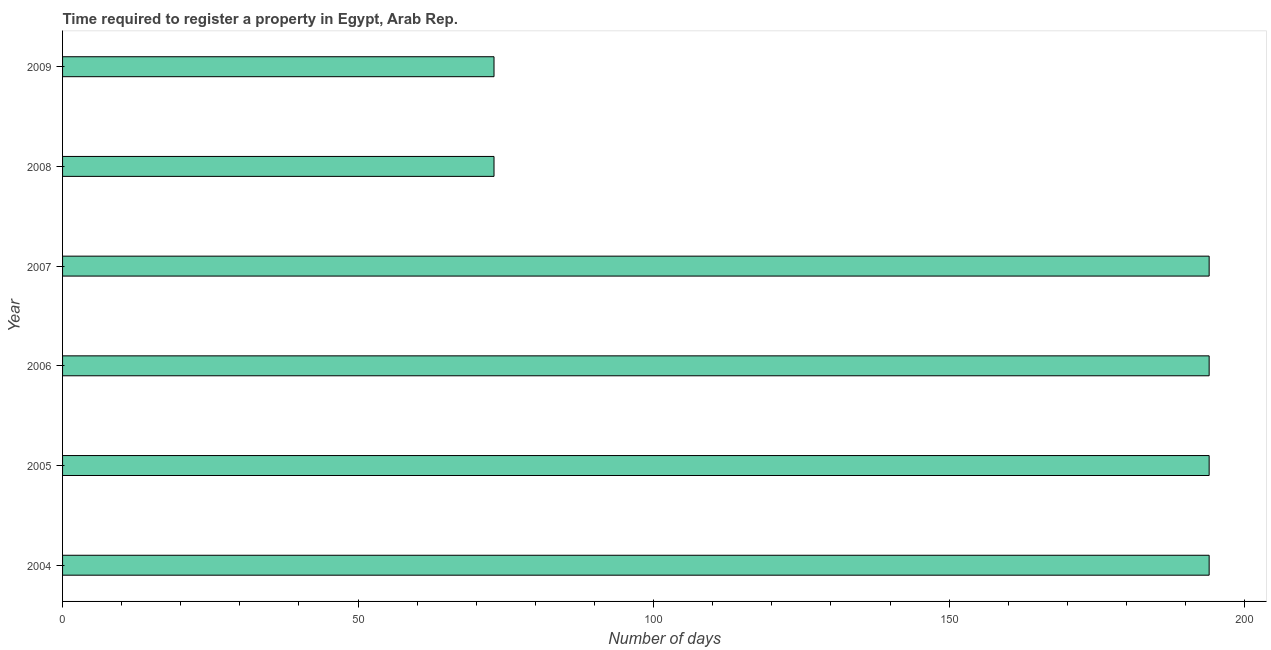What is the title of the graph?
Make the answer very short. Time required to register a property in Egypt, Arab Rep. What is the label or title of the X-axis?
Offer a very short reply. Number of days. What is the label or title of the Y-axis?
Provide a succinct answer. Year. What is the number of days required to register property in 2007?
Give a very brief answer. 194. Across all years, what is the maximum number of days required to register property?
Offer a terse response. 194. In which year was the number of days required to register property maximum?
Offer a terse response. 2004. In which year was the number of days required to register property minimum?
Ensure brevity in your answer.  2008. What is the sum of the number of days required to register property?
Provide a succinct answer. 922. What is the average number of days required to register property per year?
Provide a succinct answer. 153. What is the median number of days required to register property?
Give a very brief answer. 194. In how many years, is the number of days required to register property greater than 30 days?
Your response must be concise. 6. What is the ratio of the number of days required to register property in 2008 to that in 2009?
Your answer should be compact. 1. What is the difference between the highest and the second highest number of days required to register property?
Keep it short and to the point. 0. What is the difference between the highest and the lowest number of days required to register property?
Provide a short and direct response. 121. How many bars are there?
Your answer should be very brief. 6. What is the difference between two consecutive major ticks on the X-axis?
Your answer should be very brief. 50. Are the values on the major ticks of X-axis written in scientific E-notation?
Offer a very short reply. No. What is the Number of days in 2004?
Your response must be concise. 194. What is the Number of days in 2005?
Your response must be concise. 194. What is the Number of days in 2006?
Make the answer very short. 194. What is the Number of days in 2007?
Give a very brief answer. 194. What is the Number of days in 2008?
Provide a short and direct response. 73. What is the difference between the Number of days in 2004 and 2007?
Your answer should be compact. 0. What is the difference between the Number of days in 2004 and 2008?
Provide a succinct answer. 121. What is the difference between the Number of days in 2004 and 2009?
Your answer should be compact. 121. What is the difference between the Number of days in 2005 and 2006?
Keep it short and to the point. 0. What is the difference between the Number of days in 2005 and 2008?
Your response must be concise. 121. What is the difference between the Number of days in 2005 and 2009?
Your response must be concise. 121. What is the difference between the Number of days in 2006 and 2008?
Keep it short and to the point. 121. What is the difference between the Number of days in 2006 and 2009?
Ensure brevity in your answer.  121. What is the difference between the Number of days in 2007 and 2008?
Give a very brief answer. 121. What is the difference between the Number of days in 2007 and 2009?
Provide a succinct answer. 121. What is the difference between the Number of days in 2008 and 2009?
Keep it short and to the point. 0. What is the ratio of the Number of days in 2004 to that in 2007?
Ensure brevity in your answer.  1. What is the ratio of the Number of days in 2004 to that in 2008?
Your answer should be very brief. 2.66. What is the ratio of the Number of days in 2004 to that in 2009?
Your answer should be compact. 2.66. What is the ratio of the Number of days in 2005 to that in 2006?
Keep it short and to the point. 1. What is the ratio of the Number of days in 2005 to that in 2008?
Your response must be concise. 2.66. What is the ratio of the Number of days in 2005 to that in 2009?
Make the answer very short. 2.66. What is the ratio of the Number of days in 2006 to that in 2008?
Keep it short and to the point. 2.66. What is the ratio of the Number of days in 2006 to that in 2009?
Make the answer very short. 2.66. What is the ratio of the Number of days in 2007 to that in 2008?
Your response must be concise. 2.66. What is the ratio of the Number of days in 2007 to that in 2009?
Provide a succinct answer. 2.66. 